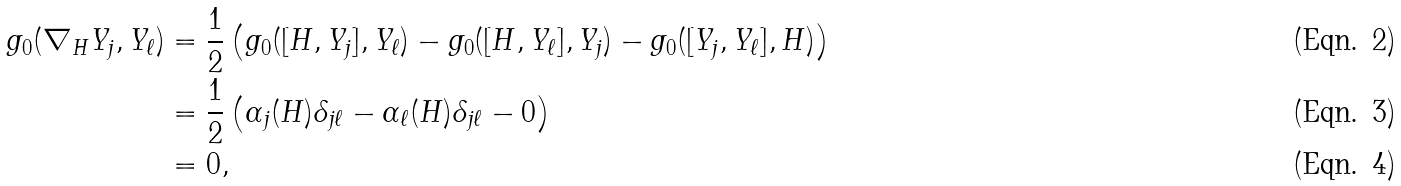Convert formula to latex. <formula><loc_0><loc_0><loc_500><loc_500>g _ { 0 } ( \nabla _ { H } Y _ { j } , Y _ { \ell } ) & = \frac { 1 } { 2 } \left ( g _ { 0 } ( [ H , Y _ { j } ] , Y _ { \ell } ) - g _ { 0 } ( [ H , Y _ { \ell } ] , Y _ { j } ) - g _ { 0 } ( [ Y _ { j } , Y _ { \ell } ] , H ) \right ) \\ & = \frac { 1 } { 2 } \left ( \alpha _ { j } ( H ) \delta _ { j \ell } - \alpha _ { \ell } ( H ) \delta _ { j \ell } - 0 \right ) \\ & = 0 ,</formula> 